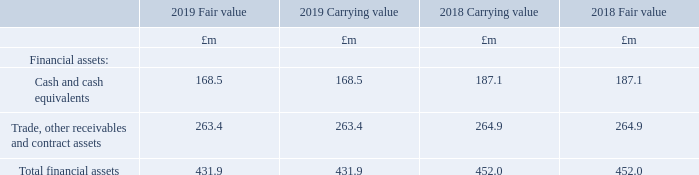Fair values of financial assets and financial liabilities
Fair values of financial assets and liabilities at 31st December 2019 are not materially different from book values due to their size or the fact that they were at short-term rates of interest. Fair values have been assessed as follows:
• Derivatives Forward exchange contracts are marked to market by discounting the future contracted cash flows using readily available market data
• Interest-bearing loans and borrowings Fair value is calculated based on discounted expected future principal and interest cash flows.
• Lease liabilities The fair value is estimated as the present value of future cash flows, discounted at the incremental borrowing rate for the related geographical location unless the rate implicit in the lease is readily determinable.
• Trade and other receivables/payables For receivables/payables with a remaining life of less than one year, the notional amount is deemed to reflect the fair value.
The following table compares amounts and fair values of the Group’s financial assets and liabilities:
There are no other assets or liabilities measured at fair value on a recurring or non-recurring basis for which fair value is disclosed.
Derivative financial instruments are measured at fair value. Fair value of derivative financial instruments are calculated based on discounted cash flow analysis using appropriate market information for the duration of the instruments.
Why are the fair values of financial assets and liabilities at 2019 not materially different from book values? Due to their size or the fact that they were at short-term rates of interest. How are forward exchange contracts marked to market? By discounting the future contracted cash flows using readily available market data. What are the components under financial assets? Cash and cash equivalents, trade, other receivables and contract assets. In which year was the carrying value for trade, other receivables and contract assets larger? 264.9>263.4
Answer: 2018. What was the change in the carrying value in total financial assets from 2018 to 2019?
Answer scale should be: million. 431.9-452.0
Answer: -20.1. What was the percentage change in the carrying value in total financial assets from 2018 to 2019?
Answer scale should be: percent. (431.9-452.0)/452.0
Answer: -4.45. 